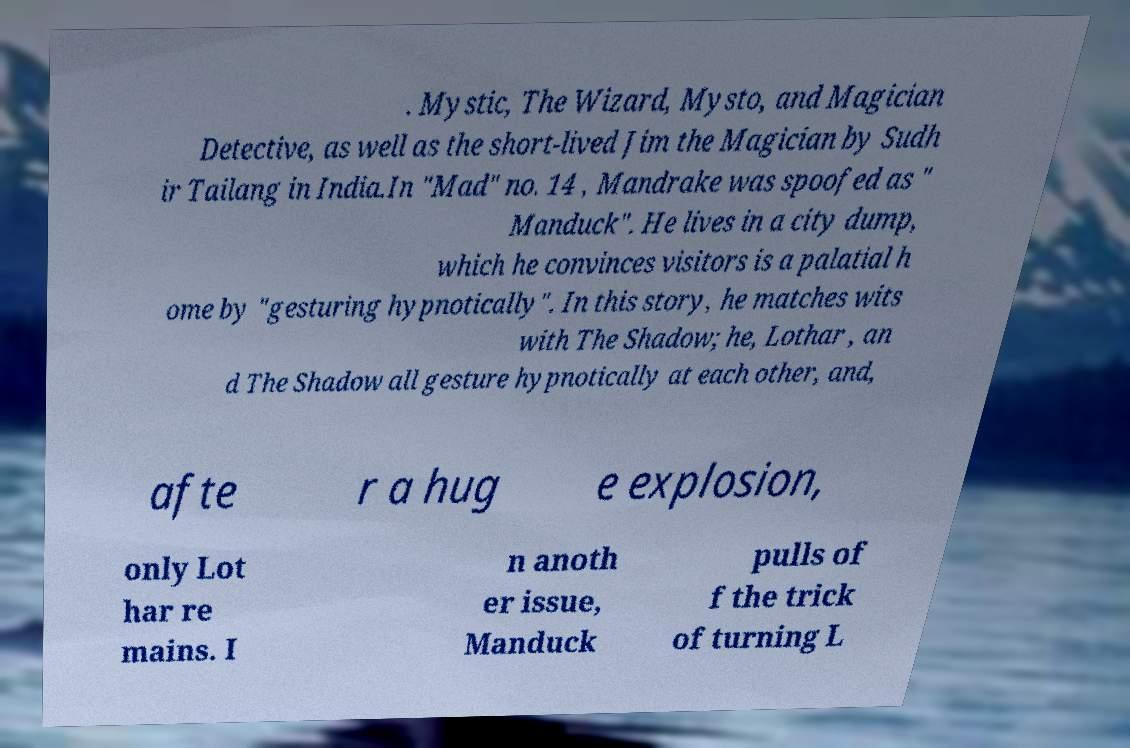I need the written content from this picture converted into text. Can you do that? . Mystic, The Wizard, Mysto, and Magician Detective, as well as the short-lived Jim the Magician by Sudh ir Tailang in India.In "Mad" no. 14 , Mandrake was spoofed as " Manduck". He lives in a city dump, which he convinces visitors is a palatial h ome by "gesturing hypnotically". In this story, he matches wits with The Shadow; he, Lothar , an d The Shadow all gesture hypnotically at each other, and, afte r a hug e explosion, only Lot har re mains. I n anoth er issue, Manduck pulls of f the trick of turning L 